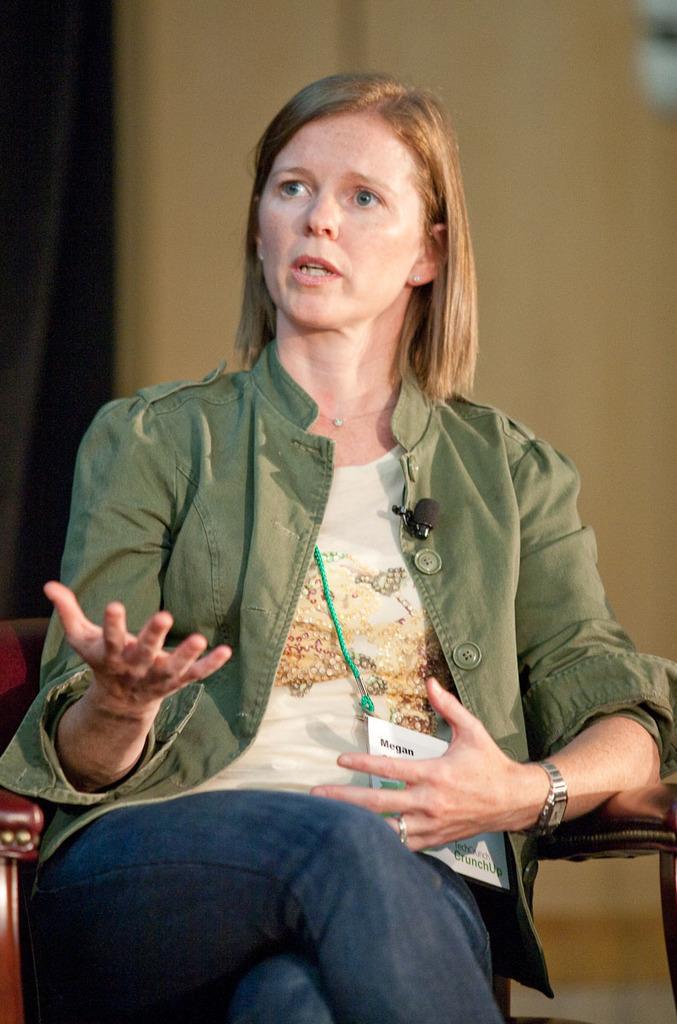Could you give a brief overview of what you see in this image? In this image we can see a woman sitting on a chair and she is speaking. Here we can see a watch on her left hand. 